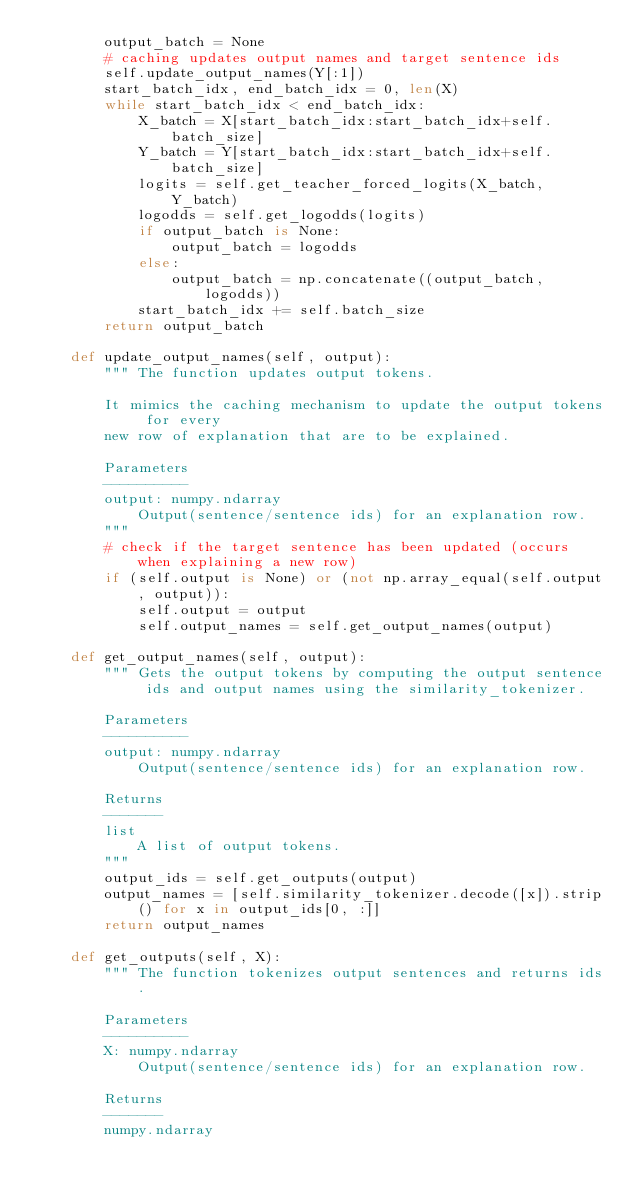Convert code to text. <code><loc_0><loc_0><loc_500><loc_500><_Python_>        output_batch = None
        # caching updates output names and target sentence ids
        self.update_output_names(Y[:1])
        start_batch_idx, end_batch_idx = 0, len(X)
        while start_batch_idx < end_batch_idx:
            X_batch = X[start_batch_idx:start_batch_idx+self.batch_size]
            Y_batch = Y[start_batch_idx:start_batch_idx+self.batch_size]
            logits = self.get_teacher_forced_logits(X_batch, Y_batch)
            logodds = self.get_logodds(logits)
            if output_batch is None:
                output_batch = logodds
            else:
                output_batch = np.concatenate((output_batch, logodds))
            start_batch_idx += self.batch_size
        return output_batch

    def update_output_names(self, output):
        """ The function updates output tokens.

        It mimics the caching mechanism to update the output tokens for every
        new row of explanation that are to be explained.

        Parameters
        ----------
        output: numpy.ndarray
            Output(sentence/sentence ids) for an explanation row.
        """
        # check if the target sentence has been updated (occurs when explaining a new row)
        if (self.output is None) or (not np.array_equal(self.output, output)):
            self.output = output
            self.output_names = self.get_output_names(output)

    def get_output_names(self, output):
        """ Gets the output tokens by computing the output sentence ids and output names using the similarity_tokenizer.

        Parameters
        ----------
        output: numpy.ndarray
            Output(sentence/sentence ids) for an explanation row.

        Returns
        -------
        list
            A list of output tokens.
        """
        output_ids = self.get_outputs(output)
        output_names = [self.similarity_tokenizer.decode([x]).strip() for x in output_ids[0, :]]
        return output_names

    def get_outputs(self, X):
        """ The function tokenizes output sentences and returns ids.

        Parameters
        ----------
        X: numpy.ndarray
            Output(sentence/sentence ids) for an explanation row.

        Returns
        -------
        numpy.ndarray</code> 